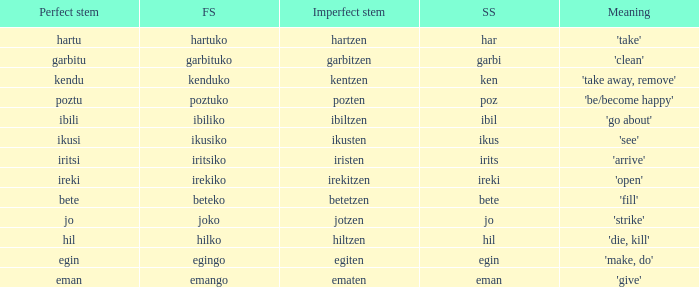What is the short stem for garbitzen? Garbi. Help me parse the entirety of this table. {'header': ['Perfect stem', 'FS', 'Imperfect stem', 'SS', 'Meaning'], 'rows': [['hartu', 'hartuko', 'hartzen', 'har', "'take'"], ['garbitu', 'garbituko', 'garbitzen', 'garbi', "'clean'"], ['kendu', 'kenduko', 'kentzen', 'ken', "'take away, remove'"], ['poztu', 'poztuko', 'pozten', 'poz', "'be/become happy'"], ['ibili', 'ibiliko', 'ibiltzen', 'ibil', "'go about'"], ['ikusi', 'ikusiko', 'ikusten', 'ikus', "'see'"], ['iritsi', 'iritsiko', 'iristen', 'irits', "'arrive'"], ['ireki', 'irekiko', 'irekitzen', 'ireki', "'open'"], ['bete', 'beteko', 'betetzen', 'bete', "'fill'"], ['jo', 'joko', 'jotzen', 'jo', "'strike'"], ['hil', 'hilko', 'hiltzen', 'hil', "'die, kill'"], ['egin', 'egingo', 'egiten', 'egin', "'make, do'"], ['eman', 'emango', 'ematen', 'eman', "'give'"]]} 